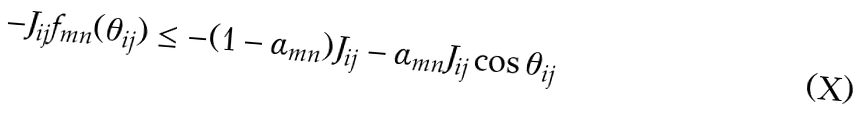Convert formula to latex. <formula><loc_0><loc_0><loc_500><loc_500>- J _ { i j } f _ { m n } ( \theta _ { i j } ) \leq - ( 1 - \alpha _ { m n } ) J _ { i j } - \alpha _ { m n } J _ { i j } \cos \theta _ { i j }</formula> 